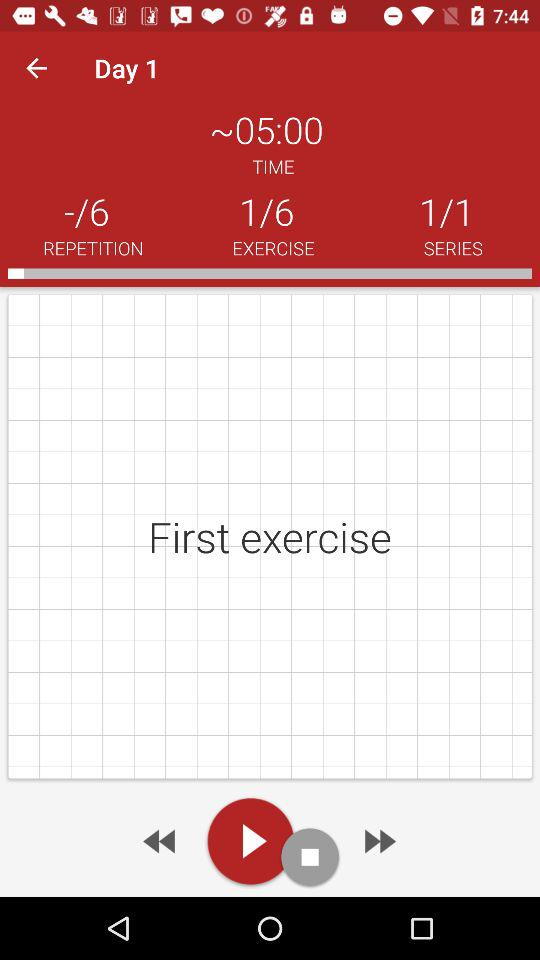What is the approximate duration for the first exercise? The approximate duration for the first exercise is 05:00. 